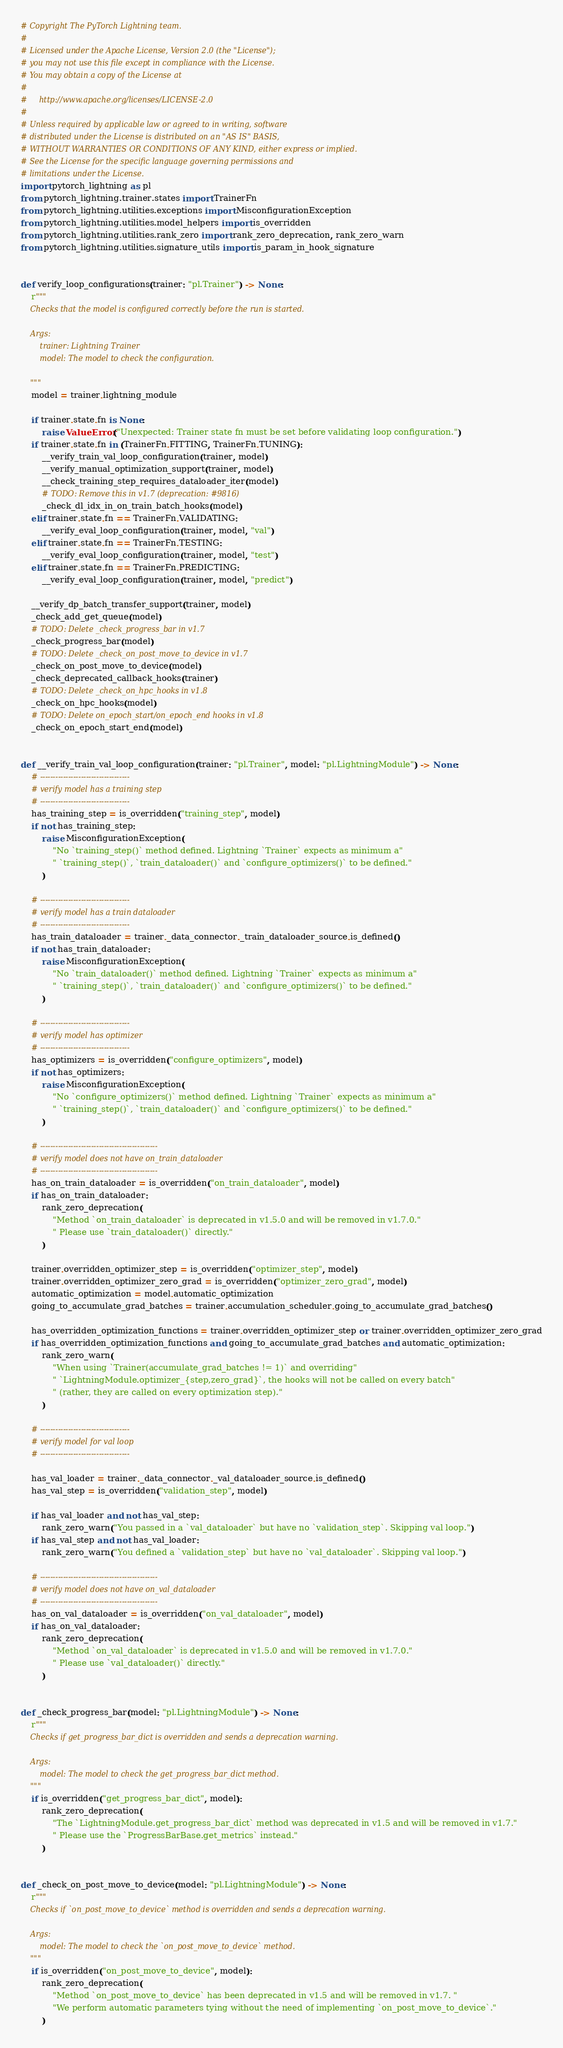<code> <loc_0><loc_0><loc_500><loc_500><_Python_># Copyright The PyTorch Lightning team.
#
# Licensed under the Apache License, Version 2.0 (the "License");
# you may not use this file except in compliance with the License.
# You may obtain a copy of the License at
#
#     http://www.apache.org/licenses/LICENSE-2.0
#
# Unless required by applicable law or agreed to in writing, software
# distributed under the License is distributed on an "AS IS" BASIS,
# WITHOUT WARRANTIES OR CONDITIONS OF ANY KIND, either express or implied.
# See the License for the specific language governing permissions and
# limitations under the License.
import pytorch_lightning as pl
from pytorch_lightning.trainer.states import TrainerFn
from pytorch_lightning.utilities.exceptions import MisconfigurationException
from pytorch_lightning.utilities.model_helpers import is_overridden
from pytorch_lightning.utilities.rank_zero import rank_zero_deprecation, rank_zero_warn
from pytorch_lightning.utilities.signature_utils import is_param_in_hook_signature


def verify_loop_configurations(trainer: "pl.Trainer") -> None:
    r"""
    Checks that the model is configured correctly before the run is started.

    Args:
        trainer: Lightning Trainer
        model: The model to check the configuration.

    """
    model = trainer.lightning_module

    if trainer.state.fn is None:
        raise ValueError("Unexpected: Trainer state fn must be set before validating loop configuration.")
    if trainer.state.fn in (TrainerFn.FITTING, TrainerFn.TUNING):
        __verify_train_val_loop_configuration(trainer, model)
        __verify_manual_optimization_support(trainer, model)
        __check_training_step_requires_dataloader_iter(model)
        # TODO: Remove this in v1.7 (deprecation: #9816)
        _check_dl_idx_in_on_train_batch_hooks(model)
    elif trainer.state.fn == TrainerFn.VALIDATING:
        __verify_eval_loop_configuration(trainer, model, "val")
    elif trainer.state.fn == TrainerFn.TESTING:
        __verify_eval_loop_configuration(trainer, model, "test")
    elif trainer.state.fn == TrainerFn.PREDICTING:
        __verify_eval_loop_configuration(trainer, model, "predict")

    __verify_dp_batch_transfer_support(trainer, model)
    _check_add_get_queue(model)
    # TODO: Delete _check_progress_bar in v1.7
    _check_progress_bar(model)
    # TODO: Delete _check_on_post_move_to_device in v1.7
    _check_on_post_move_to_device(model)
    _check_deprecated_callback_hooks(trainer)
    # TODO: Delete _check_on_hpc_hooks in v1.8
    _check_on_hpc_hooks(model)
    # TODO: Delete on_epoch_start/on_epoch_end hooks in v1.8
    _check_on_epoch_start_end(model)


def __verify_train_val_loop_configuration(trainer: "pl.Trainer", model: "pl.LightningModule") -> None:
    # -----------------------------------
    # verify model has a training step
    # -----------------------------------
    has_training_step = is_overridden("training_step", model)
    if not has_training_step:
        raise MisconfigurationException(
            "No `training_step()` method defined. Lightning `Trainer` expects as minimum a"
            " `training_step()`, `train_dataloader()` and `configure_optimizers()` to be defined."
        )

    # -----------------------------------
    # verify model has a train dataloader
    # -----------------------------------
    has_train_dataloader = trainer._data_connector._train_dataloader_source.is_defined()
    if not has_train_dataloader:
        raise MisconfigurationException(
            "No `train_dataloader()` method defined. Lightning `Trainer` expects as minimum a"
            " `training_step()`, `train_dataloader()` and `configure_optimizers()` to be defined."
        )

    # -----------------------------------
    # verify model has optimizer
    # -----------------------------------
    has_optimizers = is_overridden("configure_optimizers", model)
    if not has_optimizers:
        raise MisconfigurationException(
            "No `configure_optimizers()` method defined. Lightning `Trainer` expects as minimum a"
            " `training_step()`, `train_dataloader()` and `configure_optimizers()` to be defined."
        )

    # ----------------------------------------------
    # verify model does not have on_train_dataloader
    # ----------------------------------------------
    has_on_train_dataloader = is_overridden("on_train_dataloader", model)
    if has_on_train_dataloader:
        rank_zero_deprecation(
            "Method `on_train_dataloader` is deprecated in v1.5.0 and will be removed in v1.7.0."
            " Please use `train_dataloader()` directly."
        )

    trainer.overridden_optimizer_step = is_overridden("optimizer_step", model)
    trainer.overridden_optimizer_zero_grad = is_overridden("optimizer_zero_grad", model)
    automatic_optimization = model.automatic_optimization
    going_to_accumulate_grad_batches = trainer.accumulation_scheduler.going_to_accumulate_grad_batches()

    has_overridden_optimization_functions = trainer.overridden_optimizer_step or trainer.overridden_optimizer_zero_grad
    if has_overridden_optimization_functions and going_to_accumulate_grad_batches and automatic_optimization:
        rank_zero_warn(
            "When using `Trainer(accumulate_grad_batches != 1)` and overriding"
            " `LightningModule.optimizer_{step,zero_grad}`, the hooks will not be called on every batch"
            " (rather, they are called on every optimization step)."
        )

    # -----------------------------------
    # verify model for val loop
    # -----------------------------------

    has_val_loader = trainer._data_connector._val_dataloader_source.is_defined()
    has_val_step = is_overridden("validation_step", model)

    if has_val_loader and not has_val_step:
        rank_zero_warn("You passed in a `val_dataloader` but have no `validation_step`. Skipping val loop.")
    if has_val_step and not has_val_loader:
        rank_zero_warn("You defined a `validation_step` but have no `val_dataloader`. Skipping val loop.")

    # ----------------------------------------------
    # verify model does not have on_val_dataloader
    # ----------------------------------------------
    has_on_val_dataloader = is_overridden("on_val_dataloader", model)
    if has_on_val_dataloader:
        rank_zero_deprecation(
            "Method `on_val_dataloader` is deprecated in v1.5.0 and will be removed in v1.7.0."
            " Please use `val_dataloader()` directly."
        )


def _check_progress_bar(model: "pl.LightningModule") -> None:
    r"""
    Checks if get_progress_bar_dict is overridden and sends a deprecation warning.

    Args:
        model: The model to check the get_progress_bar_dict method.
    """
    if is_overridden("get_progress_bar_dict", model):
        rank_zero_deprecation(
            "The `LightningModule.get_progress_bar_dict` method was deprecated in v1.5 and will be removed in v1.7."
            " Please use the `ProgressBarBase.get_metrics` instead."
        )


def _check_on_post_move_to_device(model: "pl.LightningModule") -> None:
    r"""
    Checks if `on_post_move_to_device` method is overridden and sends a deprecation warning.

    Args:
        model: The model to check the `on_post_move_to_device` method.
    """
    if is_overridden("on_post_move_to_device", model):
        rank_zero_deprecation(
            "Method `on_post_move_to_device` has been deprecated in v1.5 and will be removed in v1.7. "
            "We perform automatic parameters tying without the need of implementing `on_post_move_to_device`."
        )

</code> 